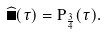Convert formula to latex. <formula><loc_0><loc_0><loc_500><loc_500>\widehat { \Sigma } ( \tau ) = P _ { \frac { 3 } { 4 } } ( \tau ) .</formula> 